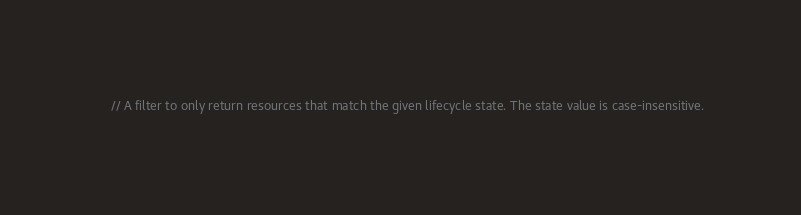<code> <loc_0><loc_0><loc_500><loc_500><_Go_>
	// A filter to only return resources that match the given lifecycle state. The state value is case-insensitive.</code> 